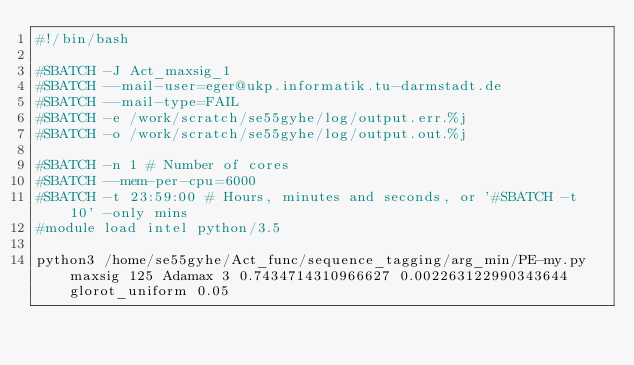<code> <loc_0><loc_0><loc_500><loc_500><_Bash_>#!/bin/bash
 
#SBATCH -J Act_maxsig_1
#SBATCH --mail-user=eger@ukp.informatik.tu-darmstadt.de
#SBATCH --mail-type=FAIL
#SBATCH -e /work/scratch/se55gyhe/log/output.err.%j
#SBATCH -o /work/scratch/se55gyhe/log/output.out.%j

#SBATCH -n 1 # Number of cores
#SBATCH --mem-per-cpu=6000
#SBATCH -t 23:59:00 # Hours, minutes and seconds, or '#SBATCH -t 10' -only mins
#module load intel python/3.5

python3 /home/se55gyhe/Act_func/sequence_tagging/arg_min/PE-my.py maxsig 125 Adamax 3 0.7434714310966627 0.002263122990343644 glorot_uniform 0.05

</code> 